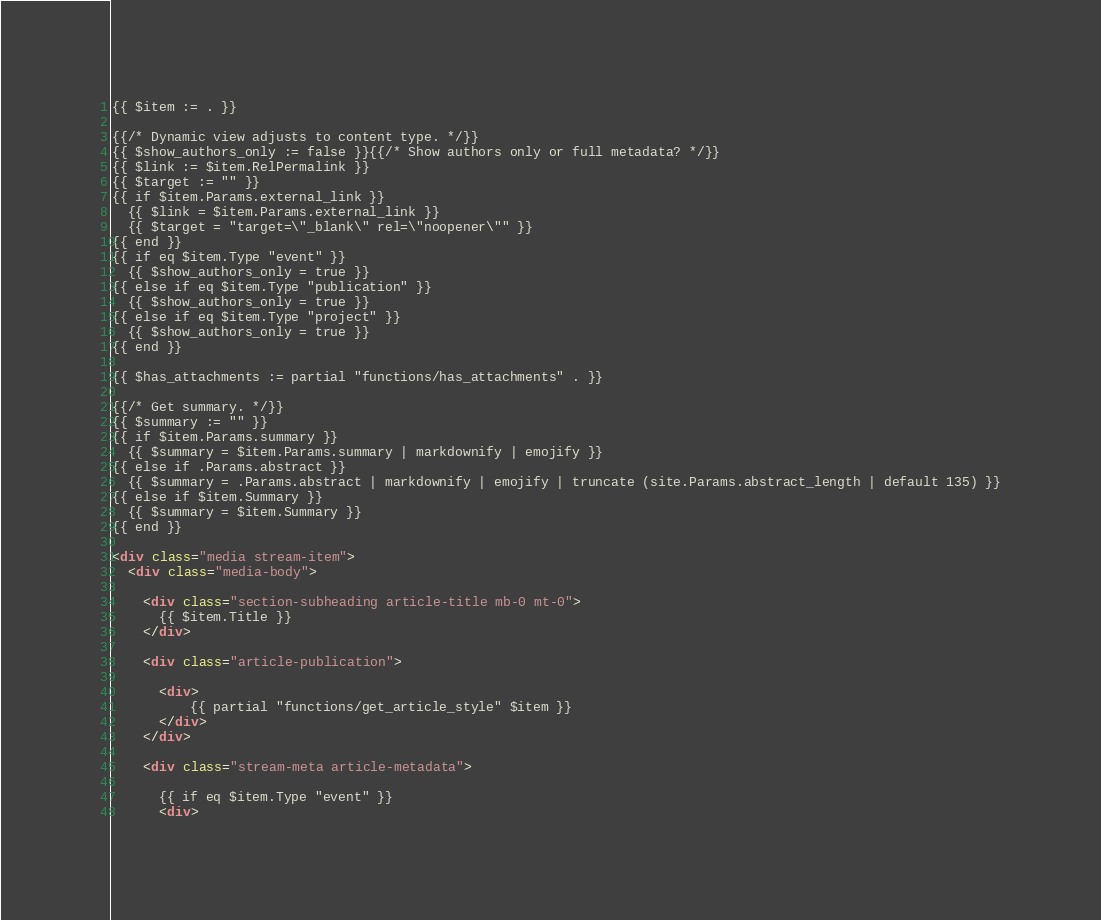<code> <loc_0><loc_0><loc_500><loc_500><_HTML_>{{ $item := . }}

{{/* Dynamic view adjusts to content type. */}}
{{ $show_authors_only := false }}{{/* Show authors only or full metadata? */}}
{{ $link := $item.RelPermalink }}
{{ $target := "" }}
{{ if $item.Params.external_link }}
  {{ $link = $item.Params.external_link }}
  {{ $target = "target=\"_blank\" rel=\"noopener\"" }}
{{ end }}
{{ if eq $item.Type "event" }}
  {{ $show_authors_only = true }}
{{ else if eq $item.Type "publication" }}
  {{ $show_authors_only = true }}
{{ else if eq $item.Type "project" }}
  {{ $show_authors_only = true }}
{{ end }}

{{ $has_attachments := partial "functions/has_attachments" . }}

{{/* Get summary. */}}
{{ $summary := "" }}
{{ if $item.Params.summary }}
  {{ $summary = $item.Params.summary | markdownify | emojify }}
{{ else if .Params.abstract }}
  {{ $summary = .Params.abstract | markdownify | emojify | truncate (site.Params.abstract_length | default 135) }}
{{ else if $item.Summary }}
  {{ $summary = $item.Summary }}
{{ end }}

<div class="media stream-item">
  <div class="media-body">

    <div class="section-subheading article-title mb-0 mt-0">
      {{ $item.Title }}
    </div>

    <div class="article-publication">

      <div>
          {{ partial "functions/get_article_style" $item }}
      </div>
    </div>

    <div class="stream-meta article-metadata">

      {{ if eq $item.Type "event" }}
      <div></code> 